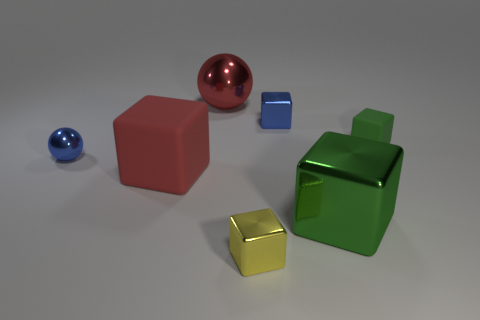Is there another green thing made of the same material as the big green object?
Your answer should be very brief. No. What material is the blue thing that is the same size as the blue block?
Provide a short and direct response. Metal. What is the color of the big block right of the red matte block behind the tiny yellow metallic thing that is on the left side of the small blue cube?
Your response must be concise. Green. There is a matte object that is to the right of the big rubber block; is it the same shape as the yellow thing that is in front of the tiny blue ball?
Provide a succinct answer. Yes. How many blue rubber spheres are there?
Provide a short and direct response. 0. There is a metallic ball that is the same size as the green metallic thing; what color is it?
Keep it short and to the point. Red. Is the material of the blue object that is in front of the tiny blue metallic block the same as the blue thing that is right of the blue ball?
Ensure brevity in your answer.  Yes. What is the size of the red thing that is to the right of the big red object in front of the tiny green object?
Provide a succinct answer. Large. What is the small yellow cube right of the tiny sphere made of?
Provide a short and direct response. Metal. How many objects are objects that are behind the tiny green thing or blue metal objects to the right of the small metallic sphere?
Ensure brevity in your answer.  2. 